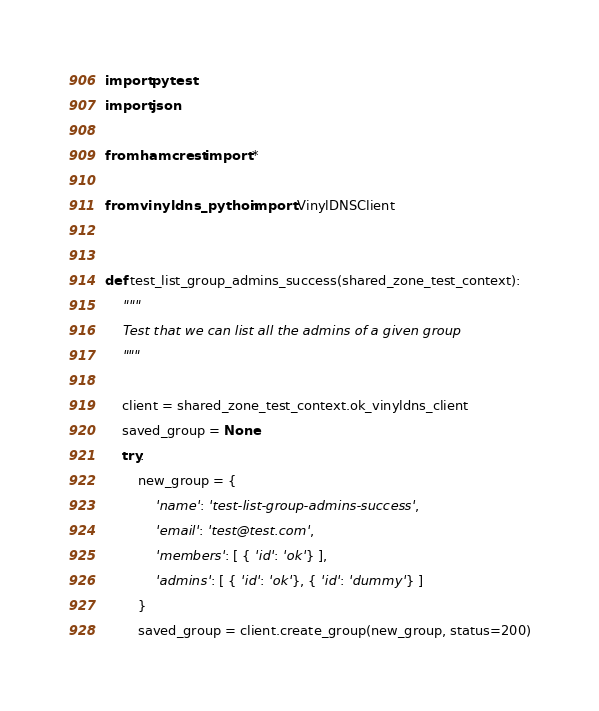<code> <loc_0><loc_0><loc_500><loc_500><_Python_>
import pytest
import json

from hamcrest import *

from vinyldns_python import VinylDNSClient


def test_list_group_admins_success(shared_zone_test_context):
    """
    Test that we can list all the admins of a given group
    """

    client = shared_zone_test_context.ok_vinyldns_client
    saved_group = None
    try:
        new_group = {
            'name': 'test-list-group-admins-success',
            'email': 'test@test.com',
            'members': [ { 'id': 'ok'} ],
            'admins': [ { 'id': 'ok'}, { 'id': 'dummy'} ]
        }
        saved_group = client.create_group(new_group, status=200)
</code> 